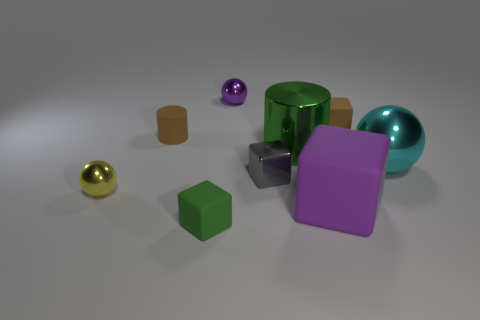Subtract all purple rubber blocks. How many blocks are left? 3 Subtract 1 cubes. How many cubes are left? 3 Subtract all purple cubes. How many cubes are left? 3 Subtract all yellow cubes. Subtract all brown balls. How many cubes are left? 4 Subtract all cubes. How many objects are left? 5 Add 6 purple rubber objects. How many purple rubber objects exist? 7 Subtract 1 cyan spheres. How many objects are left? 8 Subtract all large purple matte objects. Subtract all purple cubes. How many objects are left? 7 Add 6 shiny cylinders. How many shiny cylinders are left? 7 